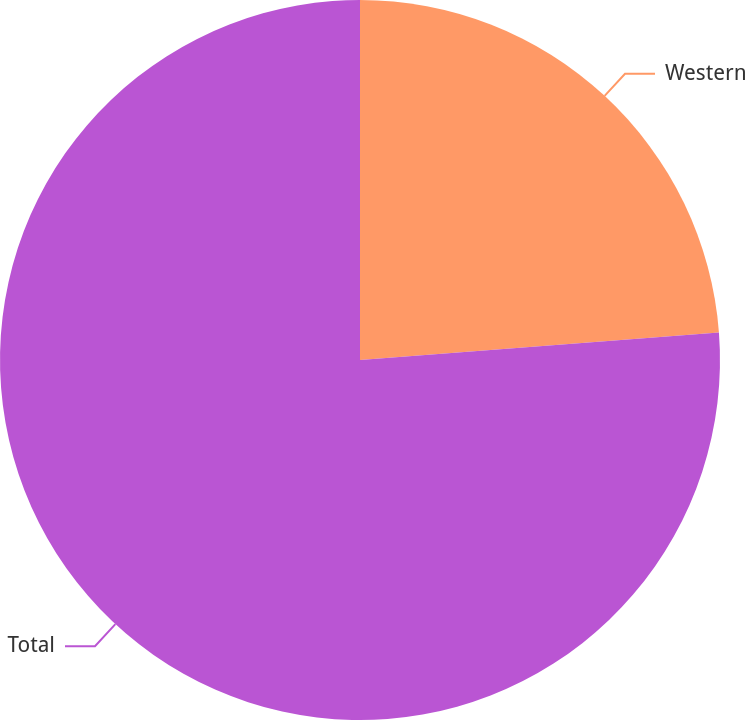<chart> <loc_0><loc_0><loc_500><loc_500><pie_chart><fcel>Western<fcel>Total<nl><fcel>23.78%<fcel>76.22%<nl></chart> 